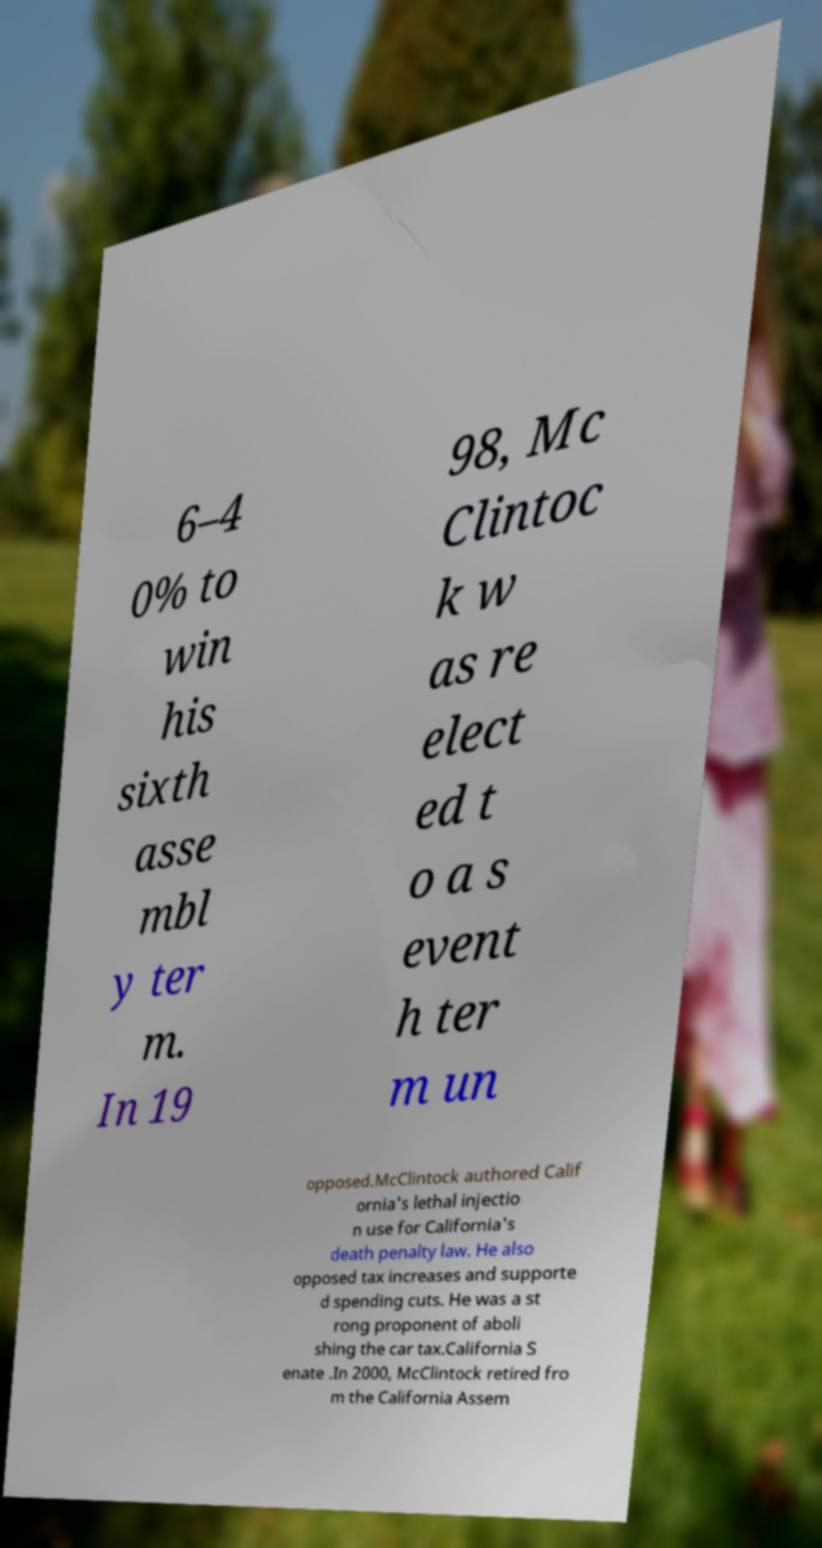There's text embedded in this image that I need extracted. Can you transcribe it verbatim? 6–4 0% to win his sixth asse mbl y ter m. In 19 98, Mc Clintoc k w as re elect ed t o a s event h ter m un opposed.McClintock authored Calif ornia's lethal injectio n use for California's death penalty law. He also opposed tax increases and supporte d spending cuts. He was a st rong proponent of aboli shing the car tax.California S enate .In 2000, McClintock retired fro m the California Assem 